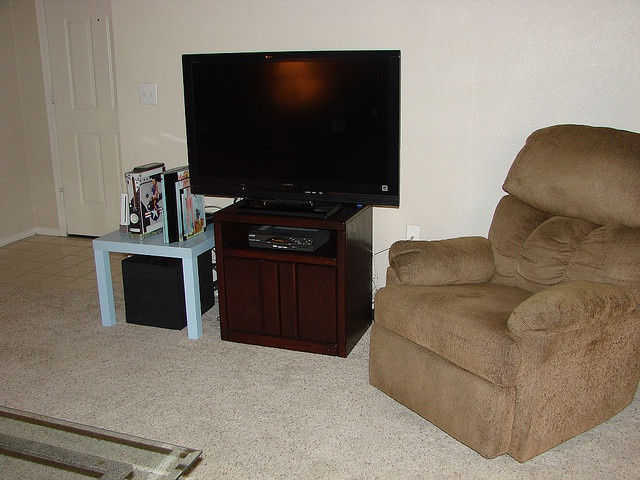Describe the objects in this image and their specific colors. I can see chair in gray tones, couch in gray tones, tv in gray, black, and maroon tones, book in gray, black, darkgray, and teal tones, and book in gray, darkgray, black, and maroon tones in this image. 